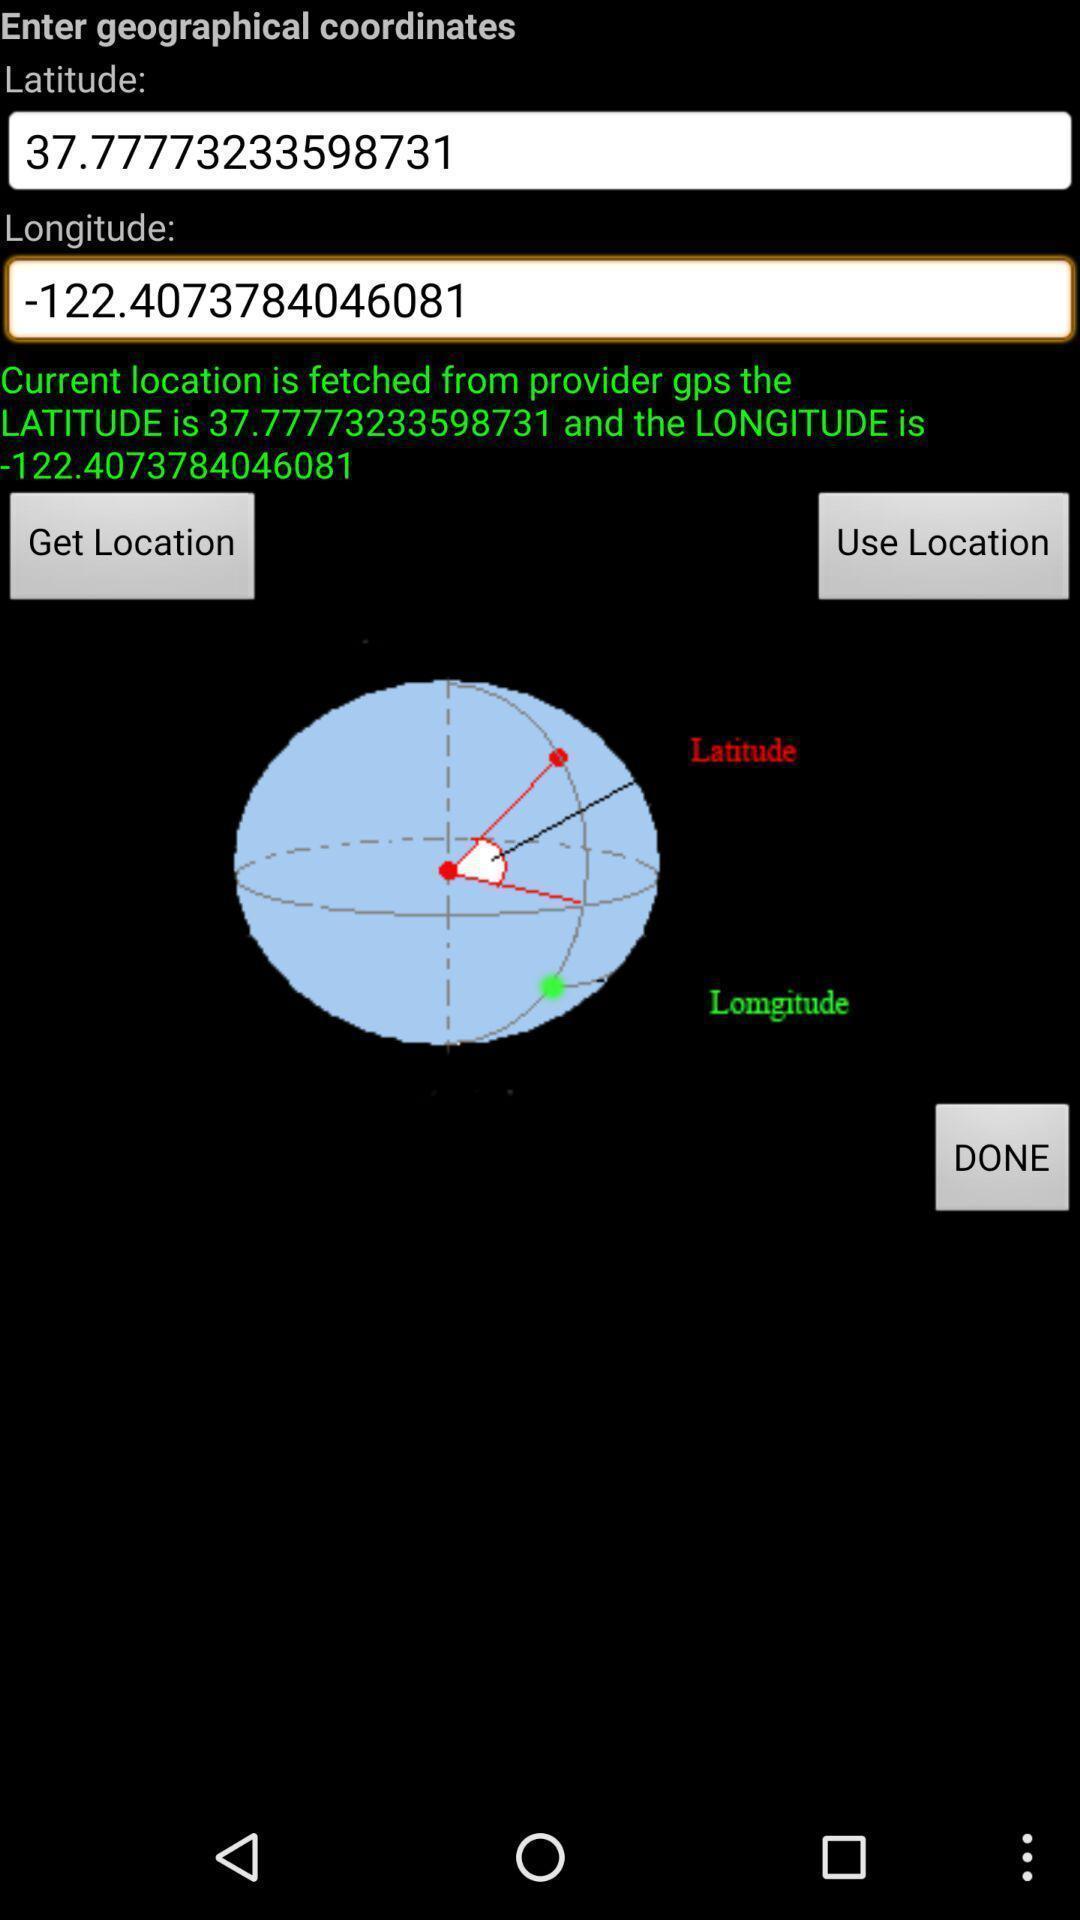Describe the content in this image. Page showing details of location on a astronomy compass app. 